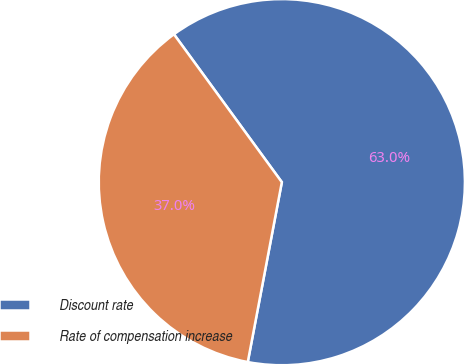Convert chart. <chart><loc_0><loc_0><loc_500><loc_500><pie_chart><fcel>Discount rate<fcel>Rate of compensation increase<nl><fcel>63.01%<fcel>36.99%<nl></chart> 